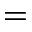Convert formula to latex. <formula><loc_0><loc_0><loc_500><loc_500>=</formula> 